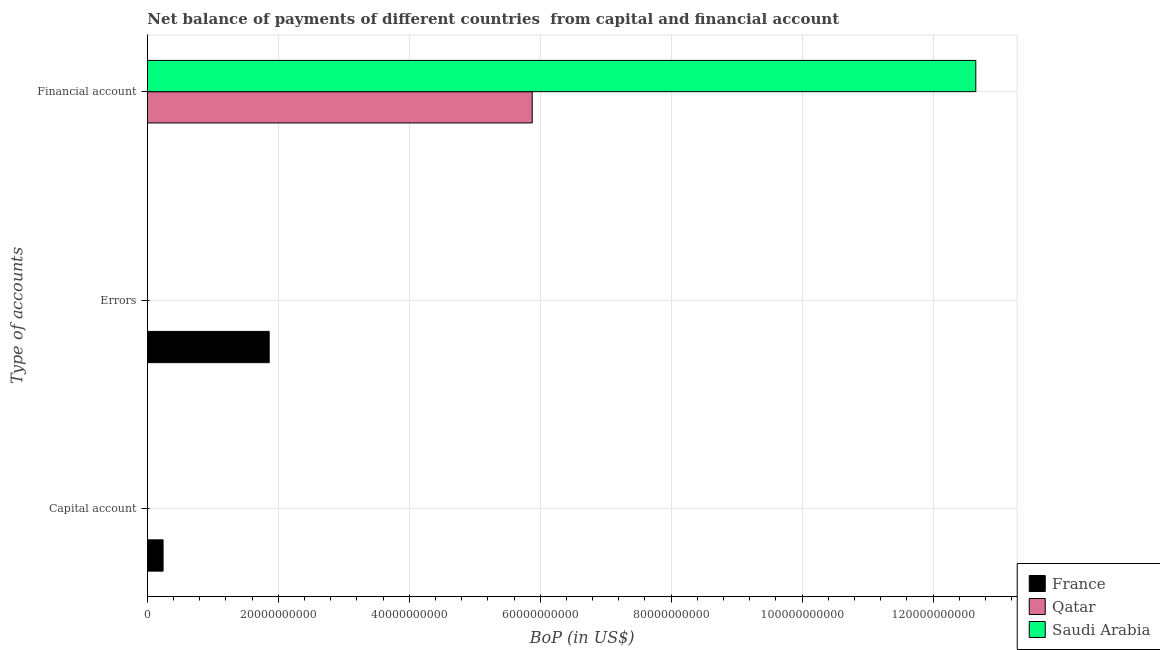Are the number of bars on each tick of the Y-axis equal?
Make the answer very short. No. How many bars are there on the 2nd tick from the top?
Keep it short and to the point. 1. What is the label of the 1st group of bars from the top?
Provide a short and direct response. Financial account. What is the amount of net capital account in France?
Ensure brevity in your answer.  2.40e+09. Across all countries, what is the maximum amount of financial account?
Provide a short and direct response. 1.27e+11. What is the total amount of financial account in the graph?
Ensure brevity in your answer.  1.85e+11. What is the difference between the amount of financial account in France and the amount of net capital account in Qatar?
Keep it short and to the point. 0. What is the average amount of errors per country?
Provide a short and direct response. 6.20e+09. What is the difference between the amount of errors and amount of net capital account in France?
Your response must be concise. 1.62e+1. In how many countries, is the amount of errors greater than 36000000000 US$?
Provide a short and direct response. 0. What is the ratio of the amount of financial account in Qatar to that in Saudi Arabia?
Offer a terse response. 0.46. What is the difference between the highest and the lowest amount of financial account?
Provide a succinct answer. 1.27e+11. How many countries are there in the graph?
Provide a short and direct response. 3. What is the difference between two consecutive major ticks on the X-axis?
Give a very brief answer. 2.00e+1. Are the values on the major ticks of X-axis written in scientific E-notation?
Give a very brief answer. No. Where does the legend appear in the graph?
Your response must be concise. Bottom right. What is the title of the graph?
Ensure brevity in your answer.  Net balance of payments of different countries  from capital and financial account. Does "Cambodia" appear as one of the legend labels in the graph?
Provide a succinct answer. No. What is the label or title of the X-axis?
Your answer should be compact. BoP (in US$). What is the label or title of the Y-axis?
Offer a very short reply. Type of accounts. What is the BoP (in US$) of France in Capital account?
Provide a short and direct response. 2.40e+09. What is the BoP (in US$) in Qatar in Capital account?
Your answer should be compact. 0. What is the BoP (in US$) of France in Errors?
Offer a very short reply. 1.86e+1. What is the BoP (in US$) in Qatar in Errors?
Offer a very short reply. 0. What is the BoP (in US$) in Qatar in Financial account?
Provide a short and direct response. 5.88e+1. What is the BoP (in US$) in Saudi Arabia in Financial account?
Your response must be concise. 1.27e+11. Across all Type of accounts, what is the maximum BoP (in US$) in France?
Keep it short and to the point. 1.86e+1. Across all Type of accounts, what is the maximum BoP (in US$) of Qatar?
Give a very brief answer. 5.88e+1. Across all Type of accounts, what is the maximum BoP (in US$) in Saudi Arabia?
Your response must be concise. 1.27e+11. Across all Type of accounts, what is the minimum BoP (in US$) of France?
Give a very brief answer. 0. What is the total BoP (in US$) of France in the graph?
Offer a very short reply. 2.10e+1. What is the total BoP (in US$) of Qatar in the graph?
Ensure brevity in your answer.  5.88e+1. What is the total BoP (in US$) of Saudi Arabia in the graph?
Give a very brief answer. 1.27e+11. What is the difference between the BoP (in US$) in France in Capital account and that in Errors?
Offer a terse response. -1.62e+1. What is the difference between the BoP (in US$) of France in Capital account and the BoP (in US$) of Qatar in Financial account?
Your response must be concise. -5.64e+1. What is the difference between the BoP (in US$) in France in Capital account and the BoP (in US$) in Saudi Arabia in Financial account?
Offer a very short reply. -1.24e+11. What is the difference between the BoP (in US$) of France in Errors and the BoP (in US$) of Qatar in Financial account?
Provide a short and direct response. -4.02e+1. What is the difference between the BoP (in US$) of France in Errors and the BoP (in US$) of Saudi Arabia in Financial account?
Provide a succinct answer. -1.08e+11. What is the average BoP (in US$) of France per Type of accounts?
Provide a succinct answer. 7.00e+09. What is the average BoP (in US$) of Qatar per Type of accounts?
Provide a succinct answer. 1.96e+1. What is the average BoP (in US$) of Saudi Arabia per Type of accounts?
Give a very brief answer. 4.22e+1. What is the difference between the BoP (in US$) of Qatar and BoP (in US$) of Saudi Arabia in Financial account?
Give a very brief answer. -6.78e+1. What is the ratio of the BoP (in US$) of France in Capital account to that in Errors?
Keep it short and to the point. 0.13. What is the difference between the highest and the lowest BoP (in US$) of France?
Ensure brevity in your answer.  1.86e+1. What is the difference between the highest and the lowest BoP (in US$) of Qatar?
Keep it short and to the point. 5.88e+1. What is the difference between the highest and the lowest BoP (in US$) in Saudi Arabia?
Your response must be concise. 1.27e+11. 